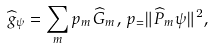Convert formula to latex. <formula><loc_0><loc_0><loc_500><loc_500>\widehat { g } _ { \psi } = \sum _ { m } p _ { m } \widehat { G } _ { m } , \, p _ { = } \| \widehat { P } _ { m } \psi \| ^ { 2 } ,</formula> 